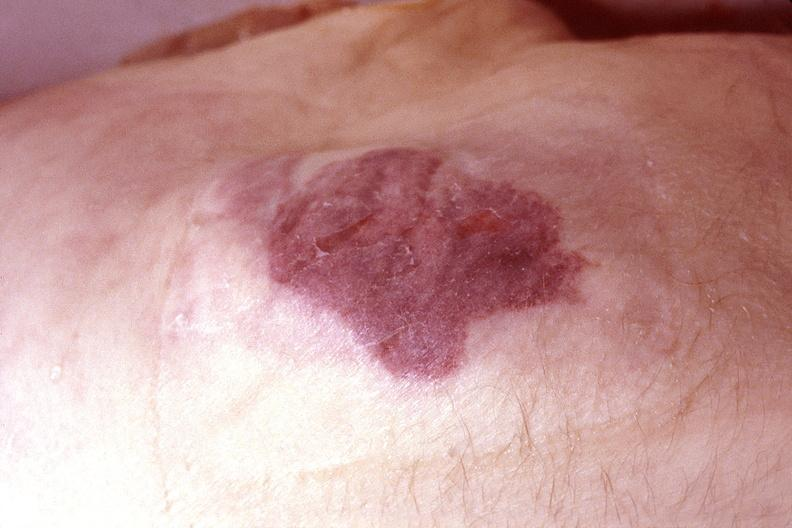where is this?
Answer the question using a single word or phrase. Skin 